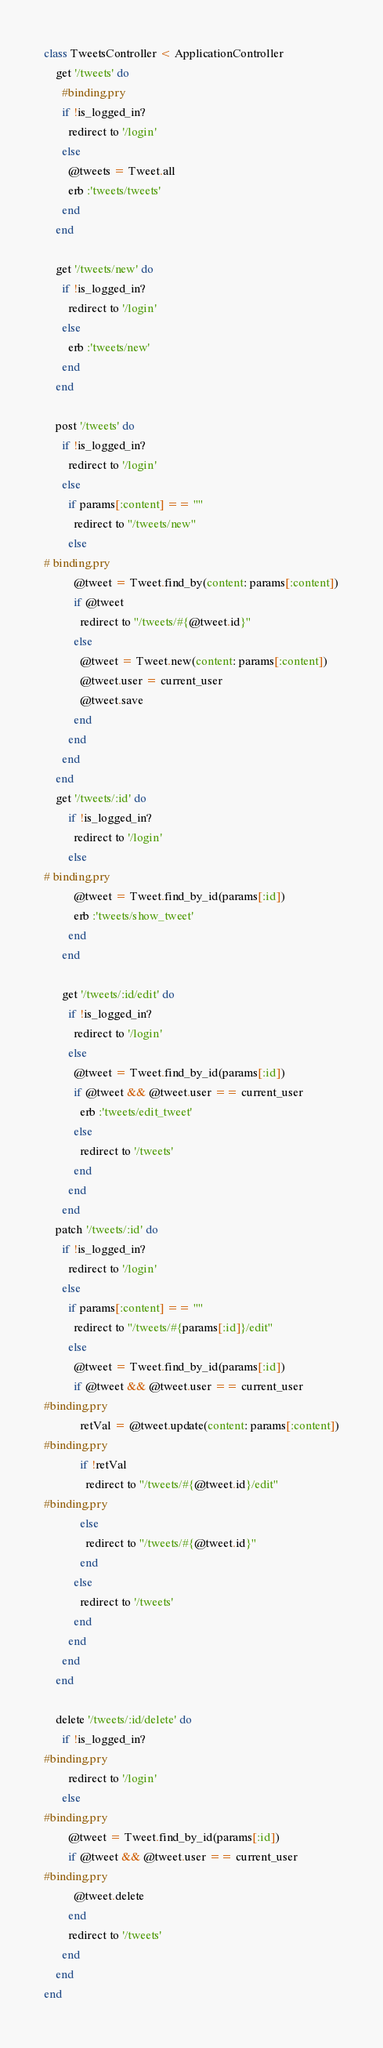<code> <loc_0><loc_0><loc_500><loc_500><_Ruby_>class TweetsController < ApplicationController
    get '/tweets' do
      #binding.pry
      if !is_logged_in?
        redirect to '/login'
      else
        @tweets = Tweet.all
        erb :'tweets/tweets'
      end
    end

    get '/tweets/new' do
      if !is_logged_in?
        redirect to '/login'
      else
        erb :'tweets/new'
      end
    end

    post '/tweets' do
      if !is_logged_in?
        redirect to '/login'
      else
        if params[:content] == ""
          redirect to "/tweets/new"
        else
# binding.pry
          @tweet = Tweet.find_by(content: params[:content])
          if @tweet
            redirect to "/tweets/#{@tweet.id}"
          else
            @tweet = Tweet.new(content: params[:content])
            @tweet.user = current_user
            @tweet.save
          end
        end
      end
    end
    get '/tweets/:id' do
        if !is_logged_in?
          redirect to '/login'
        else
# binding.pry
          @tweet = Tweet.find_by_id(params[:id])
          erb :'tweets/show_tweet'
        end
      end

      get '/tweets/:id/edit' do
        if !is_logged_in?
          redirect to '/login'
        else
          @tweet = Tweet.find_by_id(params[:id])
          if @tweet && @tweet.user == current_user
            erb :'tweets/edit_tweet'
          else
            redirect to '/tweets'
          end
        end
      end
    patch '/tweets/:id' do
      if !is_logged_in?
        redirect to '/login'
      else
        if params[:content] == ""
          redirect to "/tweets/#{params[:id]}/edit"
        else
          @tweet = Tweet.find_by_id(params[:id])
          if @tweet && @tweet.user == current_user
#binding.pry
            retVal = @tweet.update(content: params[:content])
#binding.pry
            if !retVal
              redirect to "/tweets/#{@tweet.id}/edit"
#binding.pry
            else
              redirect to "/tweets/#{@tweet.id}"
            end
          else
            redirect to '/tweets'
          end
        end
      end
    end

    delete '/tweets/:id/delete' do
      if !is_logged_in?
#binding.pry
        redirect to '/login'
      else
#binding.pry
        @tweet = Tweet.find_by_id(params[:id])
        if @tweet && @tweet.user == current_user
#binding.pry
          @tweet.delete
        end
        redirect to '/tweets'
      end
    end
end
</code> 